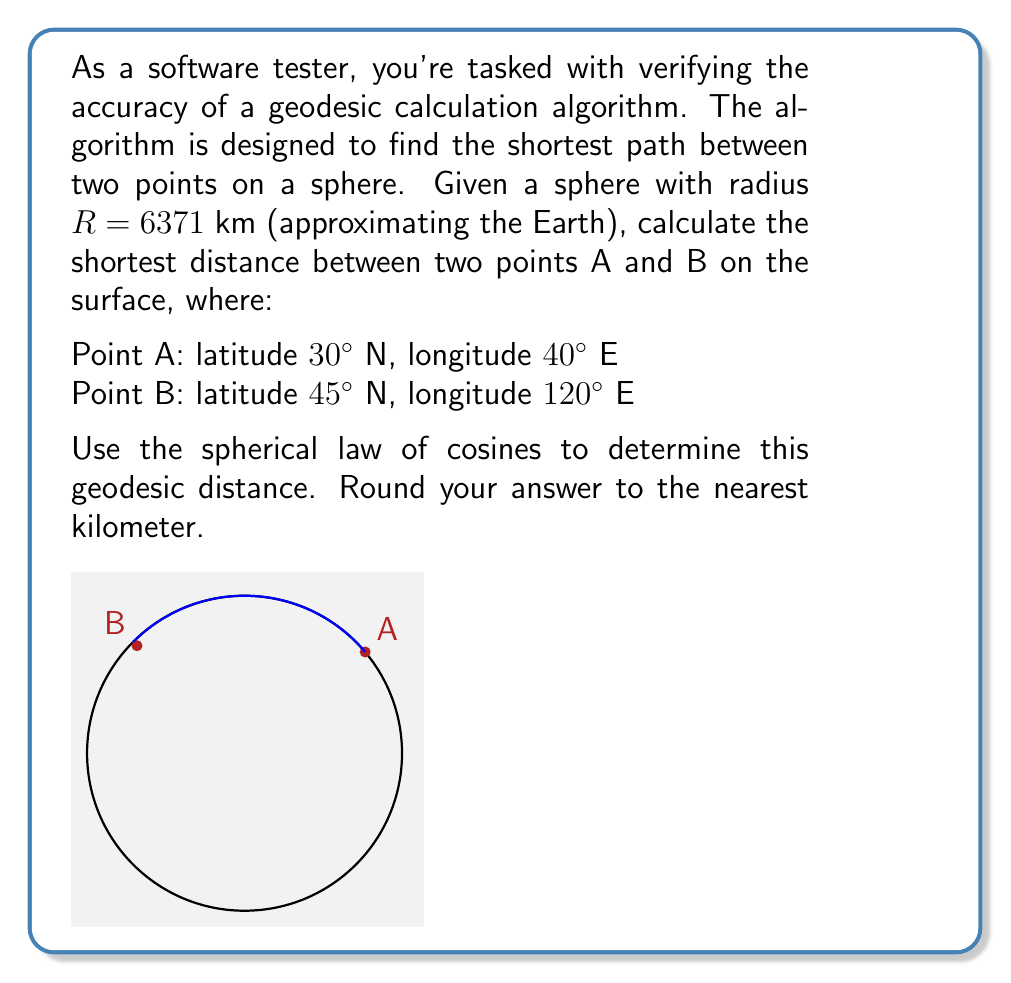Could you help me with this problem? To solve this problem, we'll use the spherical law of cosines and follow these steps:

1) Convert the latitudes and longitudes to radians:
   $\phi_1 = 30° \cdot \frac{\pi}{180} = 0.5236$ rad
   $\lambda_1 = 40° \cdot \frac{\pi}{180} = 0.6981$ rad
   $\phi_2 = 45° \cdot \frac{\pi}{180} = 0.7854$ rad
   $\lambda_2 = 120° \cdot \frac{\pi}{180} = 2.0944$ rad

2) Calculate the difference in longitude:
   $\Delta\lambda = \lambda_2 - \lambda_1 = 2.0944 - 0.6981 = 1.3963$ rad

3) Apply the spherical law of cosines:
   $$\cos(c) = \sin(\phi_1)\sin(\phi_2) + \cos(\phi_1)\cos(\phi_2)\cos(\Delta\lambda)$$

   Where $c$ is the central angle between the two points.

4) Substitute the values:
   $$\cos(c) = \sin(0.5236)\sin(0.7854) + \cos(0.5236)\cos(0.7854)\cos(1.3963)$$

5) Calculate:
   $$\cos(c) = 0.5 \cdot 0.7071 + 0.866 \cdot 0.7071 \cdot 0.1736 = 0.4619$$

6) Take the arccos to find $c$:
   $$c = \arccos(0.4619) = 1.0993 \text{ rad}$$

7) Convert the central angle to distance using the sphere's radius:
   $$d = R \cdot c = 6371 \cdot 1.0993 = 7003.4 \text{ km}$$

8) Round to the nearest kilometer:
   $$d \approx 7003 \text{ km}$$
Answer: 7003 km 